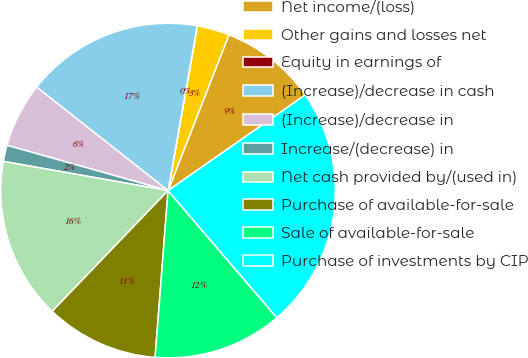<chart> <loc_0><loc_0><loc_500><loc_500><pie_chart><fcel>Net income/(loss)<fcel>Other gains and losses net<fcel>Equity in earnings of<fcel>(Increase)/decrease in cash<fcel>(Increase)/decrease in<fcel>Increase/(decrease) in<fcel>Net cash provided by/(used in)<fcel>Purchase of available-for-sale<fcel>Sale of available-for-sale<fcel>Purchase of investments by CIP<nl><fcel>9.38%<fcel>3.13%<fcel>0.01%<fcel>17.18%<fcel>6.25%<fcel>1.57%<fcel>15.62%<fcel>10.94%<fcel>12.5%<fcel>23.43%<nl></chart> 